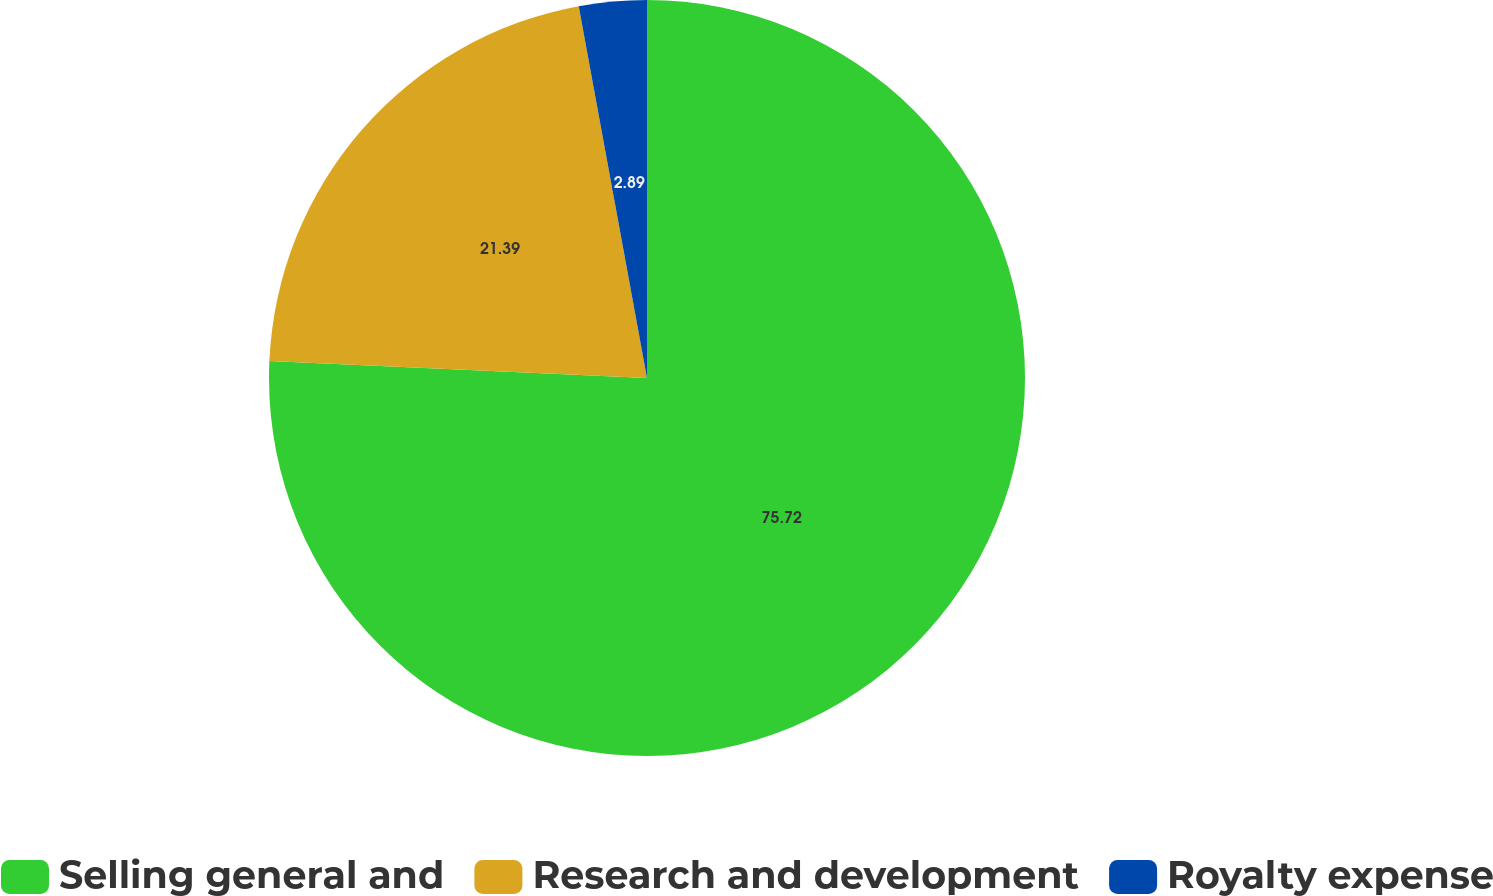<chart> <loc_0><loc_0><loc_500><loc_500><pie_chart><fcel>Selling general and<fcel>Research and development<fcel>Royalty expense<nl><fcel>75.72%<fcel>21.39%<fcel>2.89%<nl></chart> 